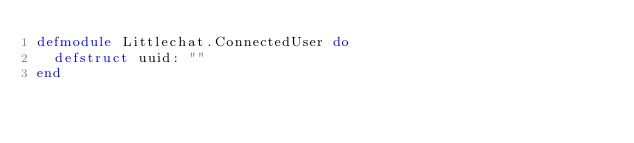Convert code to text. <code><loc_0><loc_0><loc_500><loc_500><_Elixir_>defmodule Littlechat.ConnectedUser do
  defstruct uuid: ""
end
</code> 